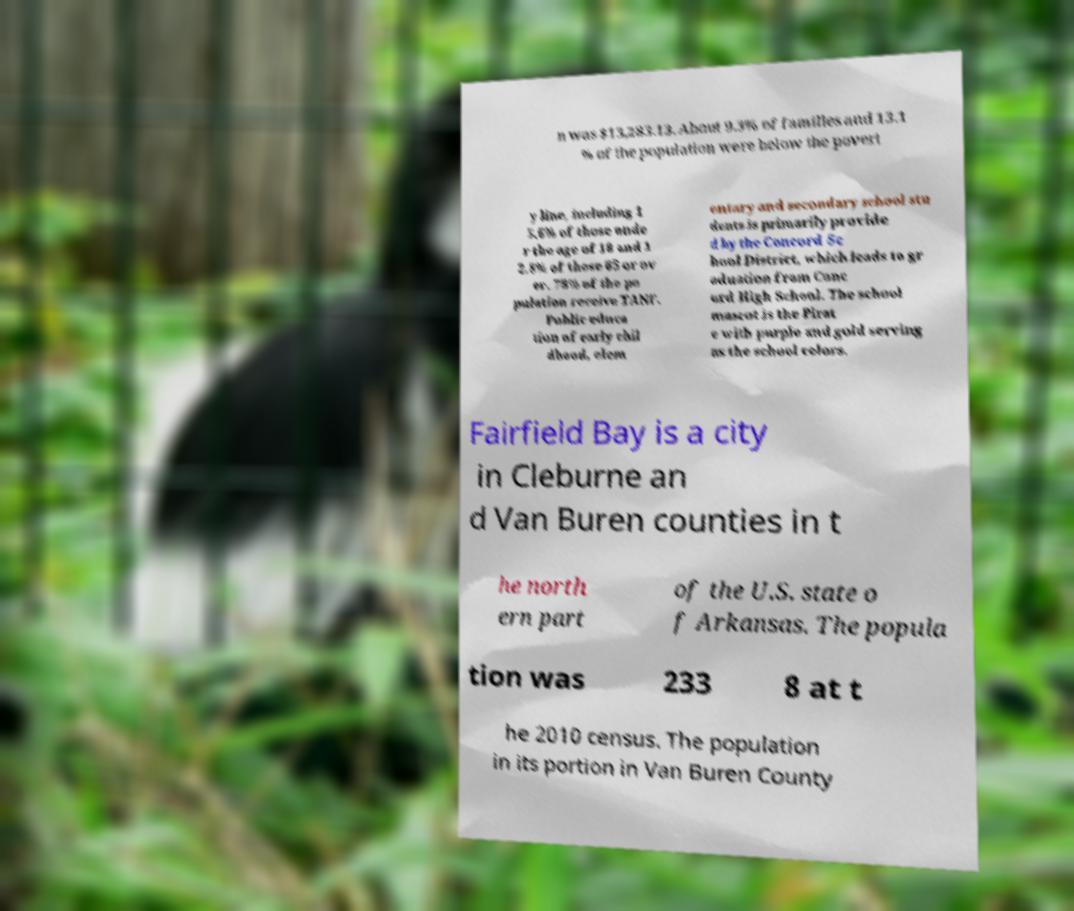Can you read and provide the text displayed in the image?This photo seems to have some interesting text. Can you extract and type it out for me? n was $13,283.13. About 9.3% of families and 13.1 % of the population were below the povert y line, including 1 5.6% of those unde r the age of 18 and 1 2.8% of those 65 or ov er. 78% of the po pulation receive TANF. Public educa tion of early chil dhood, elem entary and secondary school stu dents is primarily provide d by the Concord Sc hool District, which leads to gr aduation from Conc ord High School. The school mascot is the Pirat e with purple and gold serving as the school colors. Fairfield Bay is a city in Cleburne an d Van Buren counties in t he north ern part of the U.S. state o f Arkansas. The popula tion was 233 8 at t he 2010 census. The population in its portion in Van Buren County 